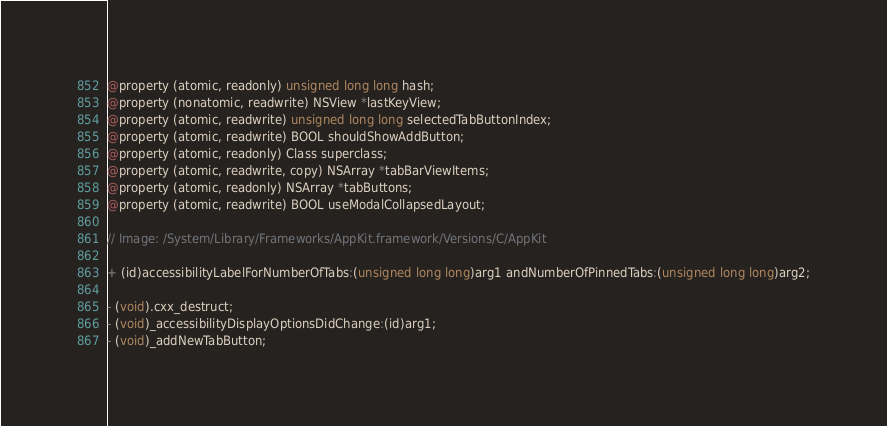<code> <loc_0><loc_0><loc_500><loc_500><_C_>@property (atomic, readonly) unsigned long long hash;
@property (nonatomic, readwrite) NSView *lastKeyView;
@property (atomic, readwrite) unsigned long long selectedTabButtonIndex;
@property (atomic, readwrite) BOOL shouldShowAddButton;
@property (atomic, readonly) Class superclass;
@property (atomic, readwrite, copy) NSArray *tabBarViewItems;
@property (atomic, readonly) NSArray *tabButtons;
@property (atomic, readwrite) BOOL useModalCollapsedLayout;

// Image: /System/Library/Frameworks/AppKit.framework/Versions/C/AppKit

+ (id)accessibilityLabelForNumberOfTabs:(unsigned long long)arg1 andNumberOfPinnedTabs:(unsigned long long)arg2;

- (void).cxx_destruct;
- (void)_accessibilityDisplayOptionsDidChange:(id)arg1;
- (void)_addNewTabButton;</code> 